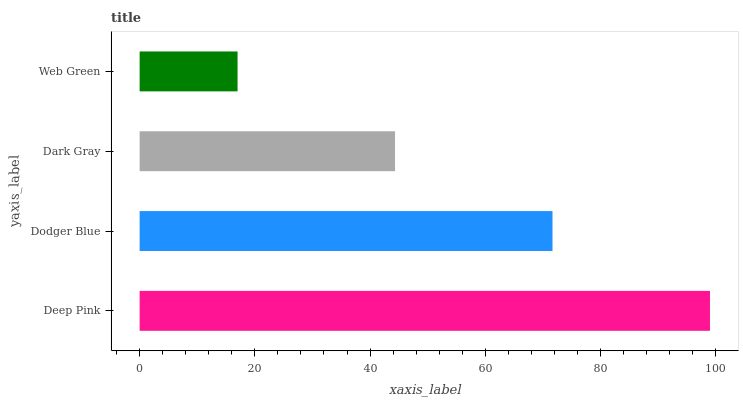Is Web Green the minimum?
Answer yes or no. Yes. Is Deep Pink the maximum?
Answer yes or no. Yes. Is Dodger Blue the minimum?
Answer yes or no. No. Is Dodger Blue the maximum?
Answer yes or no. No. Is Deep Pink greater than Dodger Blue?
Answer yes or no. Yes. Is Dodger Blue less than Deep Pink?
Answer yes or no. Yes. Is Dodger Blue greater than Deep Pink?
Answer yes or no. No. Is Deep Pink less than Dodger Blue?
Answer yes or no. No. Is Dodger Blue the high median?
Answer yes or no. Yes. Is Dark Gray the low median?
Answer yes or no. Yes. Is Dark Gray the high median?
Answer yes or no. No. Is Web Green the low median?
Answer yes or no. No. 